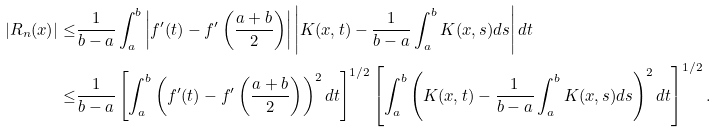Convert formula to latex. <formula><loc_0><loc_0><loc_500><loc_500>| R _ { n } ( x ) | \leq & \frac { 1 } { b - a } \int _ { a } ^ { b } \left | f ^ { \prime } ( t ) - f ^ { \prime } \left ( \frac { a + b } { 2 } \right ) \right | \left | K ( x , t ) - \frac { 1 } { b - a } \int _ { a } ^ { b } K ( x , s ) d s \right | d t \\ \leq & \frac { 1 } { b - a } \left [ \int _ { a } ^ { b } \left ( f ^ { \prime } ( t ) - f ^ { \prime } \left ( \frac { a + b } { 2 } \right ) \right ) ^ { 2 } d t \right ] ^ { 1 / 2 } \left [ \int _ { a } ^ { b } \left ( K ( x , t ) - \frac { 1 } { b - a } \int _ { a } ^ { b } K ( x , s ) d s \right ) ^ { 2 } d t \right ] ^ { 1 / 2 } .</formula> 